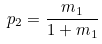Convert formula to latex. <formula><loc_0><loc_0><loc_500><loc_500>p _ { 2 } = \frac { m _ { 1 } } { 1 + m _ { 1 } }</formula> 